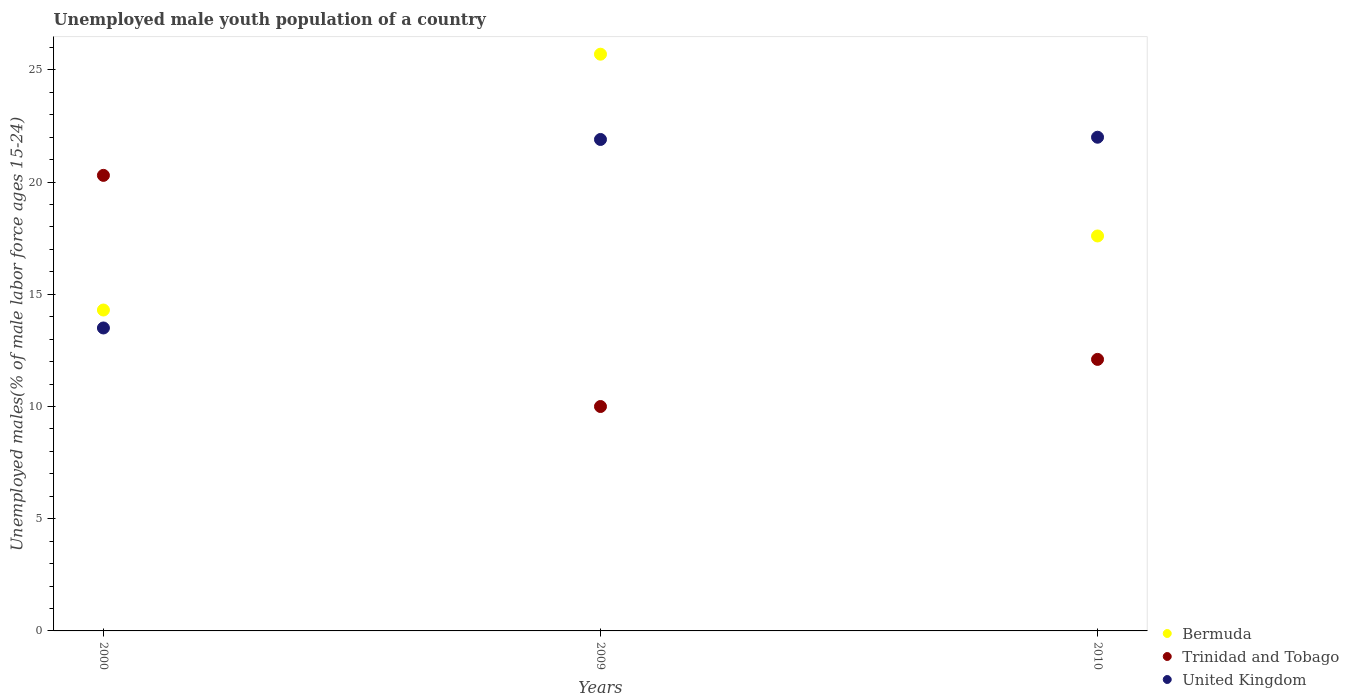What is the percentage of unemployed male youth population in United Kingdom in 2000?
Keep it short and to the point. 13.5. Across all years, what is the maximum percentage of unemployed male youth population in Trinidad and Tobago?
Make the answer very short. 20.3. Across all years, what is the minimum percentage of unemployed male youth population in Bermuda?
Give a very brief answer. 14.3. In which year was the percentage of unemployed male youth population in United Kingdom maximum?
Provide a succinct answer. 2010. In which year was the percentage of unemployed male youth population in Trinidad and Tobago minimum?
Your answer should be very brief. 2009. What is the total percentage of unemployed male youth population in Bermuda in the graph?
Provide a short and direct response. 57.6. What is the difference between the percentage of unemployed male youth population in United Kingdom in 2009 and that in 2010?
Give a very brief answer. -0.1. What is the difference between the percentage of unemployed male youth population in United Kingdom in 2000 and the percentage of unemployed male youth population in Trinidad and Tobago in 2010?
Keep it short and to the point. 1.4. What is the average percentage of unemployed male youth population in Bermuda per year?
Make the answer very short. 19.2. In the year 2009, what is the difference between the percentage of unemployed male youth population in Bermuda and percentage of unemployed male youth population in United Kingdom?
Provide a short and direct response. 3.8. In how many years, is the percentage of unemployed male youth population in Trinidad and Tobago greater than 20 %?
Make the answer very short. 1. What is the ratio of the percentage of unemployed male youth population in Bermuda in 2000 to that in 2009?
Your answer should be compact. 0.56. Is the difference between the percentage of unemployed male youth population in Bermuda in 2000 and 2009 greater than the difference between the percentage of unemployed male youth population in United Kingdom in 2000 and 2009?
Provide a short and direct response. No. What is the difference between the highest and the second highest percentage of unemployed male youth population in Trinidad and Tobago?
Keep it short and to the point. 8.2. What is the difference between the highest and the lowest percentage of unemployed male youth population in Bermuda?
Provide a short and direct response. 11.4. Is it the case that in every year, the sum of the percentage of unemployed male youth population in Trinidad and Tobago and percentage of unemployed male youth population in Bermuda  is greater than the percentage of unemployed male youth population in United Kingdom?
Provide a short and direct response. Yes. Does the percentage of unemployed male youth population in United Kingdom monotonically increase over the years?
Offer a very short reply. Yes. Is the percentage of unemployed male youth population in United Kingdom strictly less than the percentage of unemployed male youth population in Bermuda over the years?
Offer a very short reply. No. What is the difference between two consecutive major ticks on the Y-axis?
Provide a short and direct response. 5. Does the graph contain grids?
Your answer should be compact. No. Where does the legend appear in the graph?
Provide a succinct answer. Bottom right. How are the legend labels stacked?
Your response must be concise. Vertical. What is the title of the graph?
Your answer should be very brief. Unemployed male youth population of a country. What is the label or title of the Y-axis?
Offer a very short reply. Unemployed males(% of male labor force ages 15-24). What is the Unemployed males(% of male labor force ages 15-24) in Bermuda in 2000?
Your answer should be very brief. 14.3. What is the Unemployed males(% of male labor force ages 15-24) in Trinidad and Tobago in 2000?
Keep it short and to the point. 20.3. What is the Unemployed males(% of male labor force ages 15-24) of Bermuda in 2009?
Provide a succinct answer. 25.7. What is the Unemployed males(% of male labor force ages 15-24) in United Kingdom in 2009?
Offer a very short reply. 21.9. What is the Unemployed males(% of male labor force ages 15-24) of Bermuda in 2010?
Keep it short and to the point. 17.6. What is the Unemployed males(% of male labor force ages 15-24) in Trinidad and Tobago in 2010?
Provide a succinct answer. 12.1. What is the Unemployed males(% of male labor force ages 15-24) in United Kingdom in 2010?
Provide a short and direct response. 22. Across all years, what is the maximum Unemployed males(% of male labor force ages 15-24) of Bermuda?
Ensure brevity in your answer.  25.7. Across all years, what is the maximum Unemployed males(% of male labor force ages 15-24) of Trinidad and Tobago?
Offer a very short reply. 20.3. Across all years, what is the minimum Unemployed males(% of male labor force ages 15-24) in Bermuda?
Provide a succinct answer. 14.3. What is the total Unemployed males(% of male labor force ages 15-24) in Bermuda in the graph?
Your answer should be very brief. 57.6. What is the total Unemployed males(% of male labor force ages 15-24) in Trinidad and Tobago in the graph?
Make the answer very short. 42.4. What is the total Unemployed males(% of male labor force ages 15-24) of United Kingdom in the graph?
Your response must be concise. 57.4. What is the difference between the Unemployed males(% of male labor force ages 15-24) in Bermuda in 2000 and that in 2009?
Provide a short and direct response. -11.4. What is the difference between the Unemployed males(% of male labor force ages 15-24) of Trinidad and Tobago in 2000 and that in 2009?
Ensure brevity in your answer.  10.3. What is the difference between the Unemployed males(% of male labor force ages 15-24) of United Kingdom in 2000 and that in 2009?
Keep it short and to the point. -8.4. What is the difference between the Unemployed males(% of male labor force ages 15-24) in Trinidad and Tobago in 2000 and that in 2010?
Your response must be concise. 8.2. What is the difference between the Unemployed males(% of male labor force ages 15-24) of United Kingdom in 2000 and that in 2010?
Provide a succinct answer. -8.5. What is the difference between the Unemployed males(% of male labor force ages 15-24) of Bermuda in 2009 and that in 2010?
Your answer should be compact. 8.1. What is the difference between the Unemployed males(% of male labor force ages 15-24) of United Kingdom in 2009 and that in 2010?
Give a very brief answer. -0.1. What is the difference between the Unemployed males(% of male labor force ages 15-24) of Bermuda in 2000 and the Unemployed males(% of male labor force ages 15-24) of Trinidad and Tobago in 2009?
Provide a short and direct response. 4.3. What is the difference between the Unemployed males(% of male labor force ages 15-24) in Bermuda in 2000 and the Unemployed males(% of male labor force ages 15-24) in United Kingdom in 2009?
Ensure brevity in your answer.  -7.6. What is the difference between the Unemployed males(% of male labor force ages 15-24) in Trinidad and Tobago in 2000 and the Unemployed males(% of male labor force ages 15-24) in United Kingdom in 2010?
Your answer should be very brief. -1.7. What is the average Unemployed males(% of male labor force ages 15-24) of Trinidad and Tobago per year?
Offer a terse response. 14.13. What is the average Unemployed males(% of male labor force ages 15-24) in United Kingdom per year?
Offer a terse response. 19.13. In the year 2000, what is the difference between the Unemployed males(% of male labor force ages 15-24) in Bermuda and Unemployed males(% of male labor force ages 15-24) in United Kingdom?
Make the answer very short. 0.8. In the year 2009, what is the difference between the Unemployed males(% of male labor force ages 15-24) of Trinidad and Tobago and Unemployed males(% of male labor force ages 15-24) of United Kingdom?
Your response must be concise. -11.9. In the year 2010, what is the difference between the Unemployed males(% of male labor force ages 15-24) in Bermuda and Unemployed males(% of male labor force ages 15-24) in Trinidad and Tobago?
Offer a terse response. 5.5. In the year 2010, what is the difference between the Unemployed males(% of male labor force ages 15-24) of Trinidad and Tobago and Unemployed males(% of male labor force ages 15-24) of United Kingdom?
Keep it short and to the point. -9.9. What is the ratio of the Unemployed males(% of male labor force ages 15-24) of Bermuda in 2000 to that in 2009?
Offer a very short reply. 0.56. What is the ratio of the Unemployed males(% of male labor force ages 15-24) of Trinidad and Tobago in 2000 to that in 2009?
Provide a short and direct response. 2.03. What is the ratio of the Unemployed males(% of male labor force ages 15-24) in United Kingdom in 2000 to that in 2009?
Your answer should be compact. 0.62. What is the ratio of the Unemployed males(% of male labor force ages 15-24) in Bermuda in 2000 to that in 2010?
Your answer should be compact. 0.81. What is the ratio of the Unemployed males(% of male labor force ages 15-24) in Trinidad and Tobago in 2000 to that in 2010?
Your response must be concise. 1.68. What is the ratio of the Unemployed males(% of male labor force ages 15-24) of United Kingdom in 2000 to that in 2010?
Your answer should be compact. 0.61. What is the ratio of the Unemployed males(% of male labor force ages 15-24) of Bermuda in 2009 to that in 2010?
Provide a succinct answer. 1.46. What is the ratio of the Unemployed males(% of male labor force ages 15-24) of Trinidad and Tobago in 2009 to that in 2010?
Ensure brevity in your answer.  0.83. What is the ratio of the Unemployed males(% of male labor force ages 15-24) in United Kingdom in 2009 to that in 2010?
Offer a very short reply. 1. What is the difference between the highest and the lowest Unemployed males(% of male labor force ages 15-24) of United Kingdom?
Give a very brief answer. 8.5. 